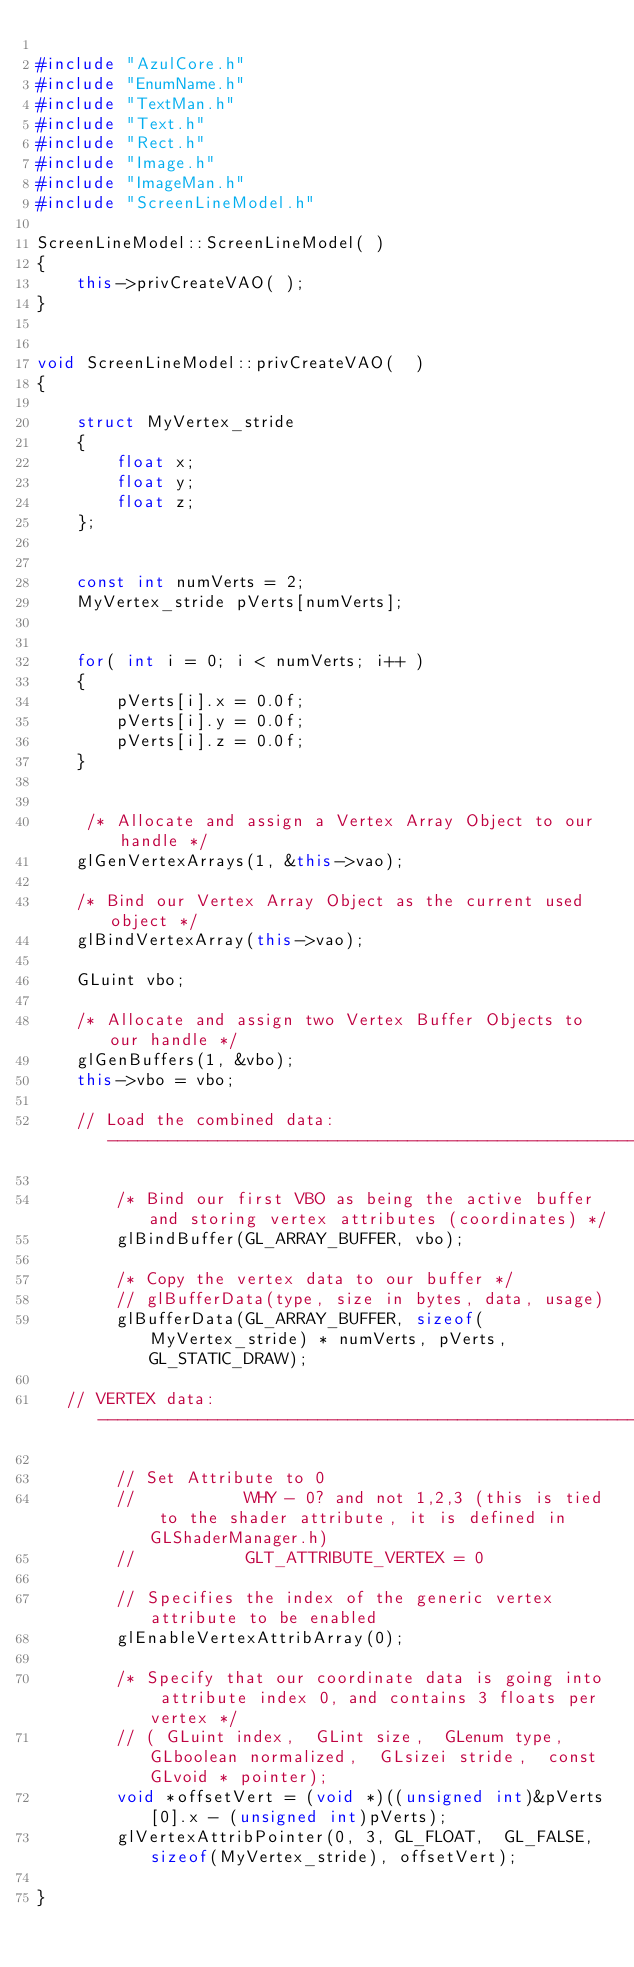<code> <loc_0><loc_0><loc_500><loc_500><_C++_>
#include "AzulCore.h"
#include "EnumName.h"
#include "TextMan.h"
#include "Text.h"
#include "Rect.h"
#include "Image.h"
#include "ImageMan.h"
#include "ScreenLineModel.h"

ScreenLineModel::ScreenLineModel( )
{	
	this->privCreateVAO( );
}


void ScreenLineModel::privCreateVAO(  )
{

	struct MyVertex_stride
	{
		float x;
		float y;
		float z;
	};


	const int numVerts = 2;
	MyVertex_stride pVerts[numVerts];

	
	for( int i = 0; i < numVerts; i++ )
	{
		pVerts[i].x = 0.0f;
		pVerts[i].y = 0.0f;
		pVerts[i].z = 0.0f;
	}


     /* Allocate and assign a Vertex Array Object to our handle */
    glGenVertexArrays(1, &this->vao);
 
    /* Bind our Vertex Array Object as the current used object */
    glBindVertexArray(this->vao);

    GLuint vbo;

    /* Allocate and assign two Vertex Buffer Objects to our handle */
    glGenBuffers(1, &vbo);
	this->vbo = vbo;

    // Load the combined data: ---------------------------------------------------------

		/* Bind our first VBO as being the active buffer and storing vertex attributes (coordinates) */
		glBindBuffer(GL_ARRAY_BUFFER, vbo);
 
		/* Copy the vertex data to our buffer */
		// glBufferData(type, size in bytes, data, usage) 
		glBufferData(GL_ARRAY_BUFFER, sizeof(MyVertex_stride) * numVerts, pVerts, GL_STATIC_DRAW);
		
   // VERTEX data: ---------------------------------------------------------

		// Set Attribute to 0
		//           WHY - 0? and not 1,2,3 (this is tied to the shader attribute, it is defined in GLShaderManager.h)
		//           GLT_ATTRIBUTE_VERTEX = 0

		// Specifies the index of the generic vertex attribute to be enabled
		glEnableVertexAttribArray(0);  

		/* Specify that our coordinate data is going into attribute index 0, and contains 3 floats per vertex */
		// ( GLuint index,  GLint size,  GLenum type,  GLboolean normalized,  GLsizei stride,  const GLvoid * pointer);
		void *offsetVert = (void *)((unsigned int)&pVerts[0].x - (unsigned int)pVerts);
		glVertexAttribPointer(0, 3, GL_FLOAT,  GL_FALSE, sizeof(MyVertex_stride), offsetVert);
		 
}




</code> 